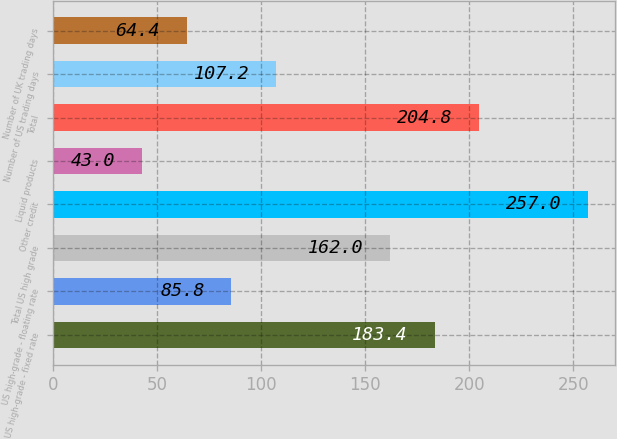Convert chart to OTSL. <chart><loc_0><loc_0><loc_500><loc_500><bar_chart><fcel>US high-grade - fixed rate<fcel>US high-grade - floating rate<fcel>Total US high grade<fcel>Other credit<fcel>Liquid products<fcel>Total<fcel>Number of US trading days<fcel>Number of UK trading days<nl><fcel>183.4<fcel>85.8<fcel>162<fcel>257<fcel>43<fcel>204.8<fcel>107.2<fcel>64.4<nl></chart> 